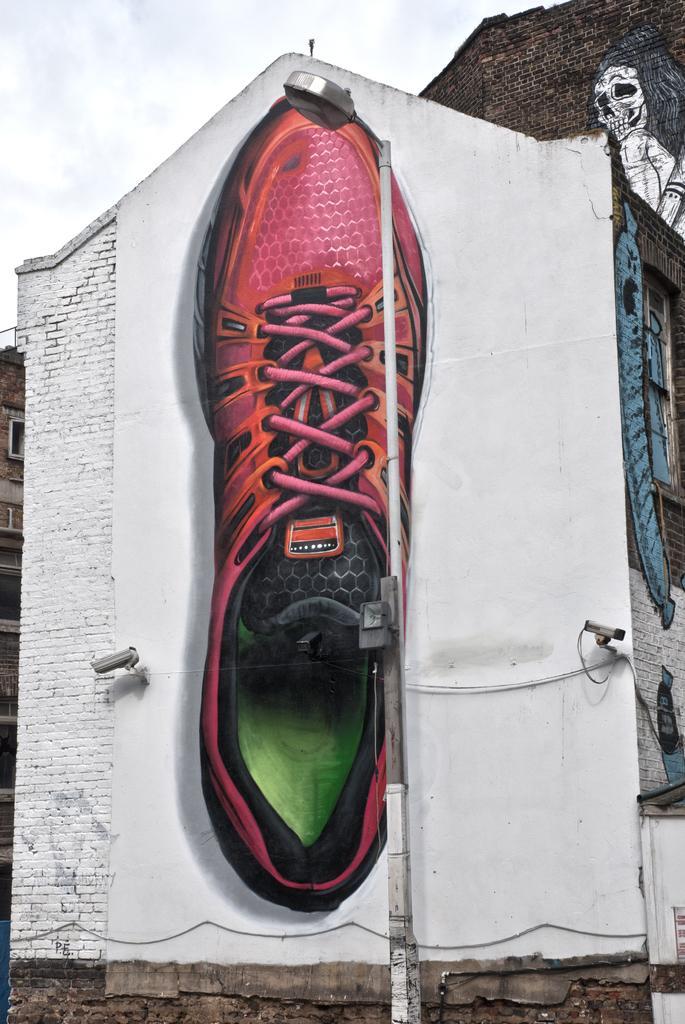How would you summarize this image in a sentence or two? In this picture we can see some paintings on the buildings. There is a street light. We can see a building on the left side. 